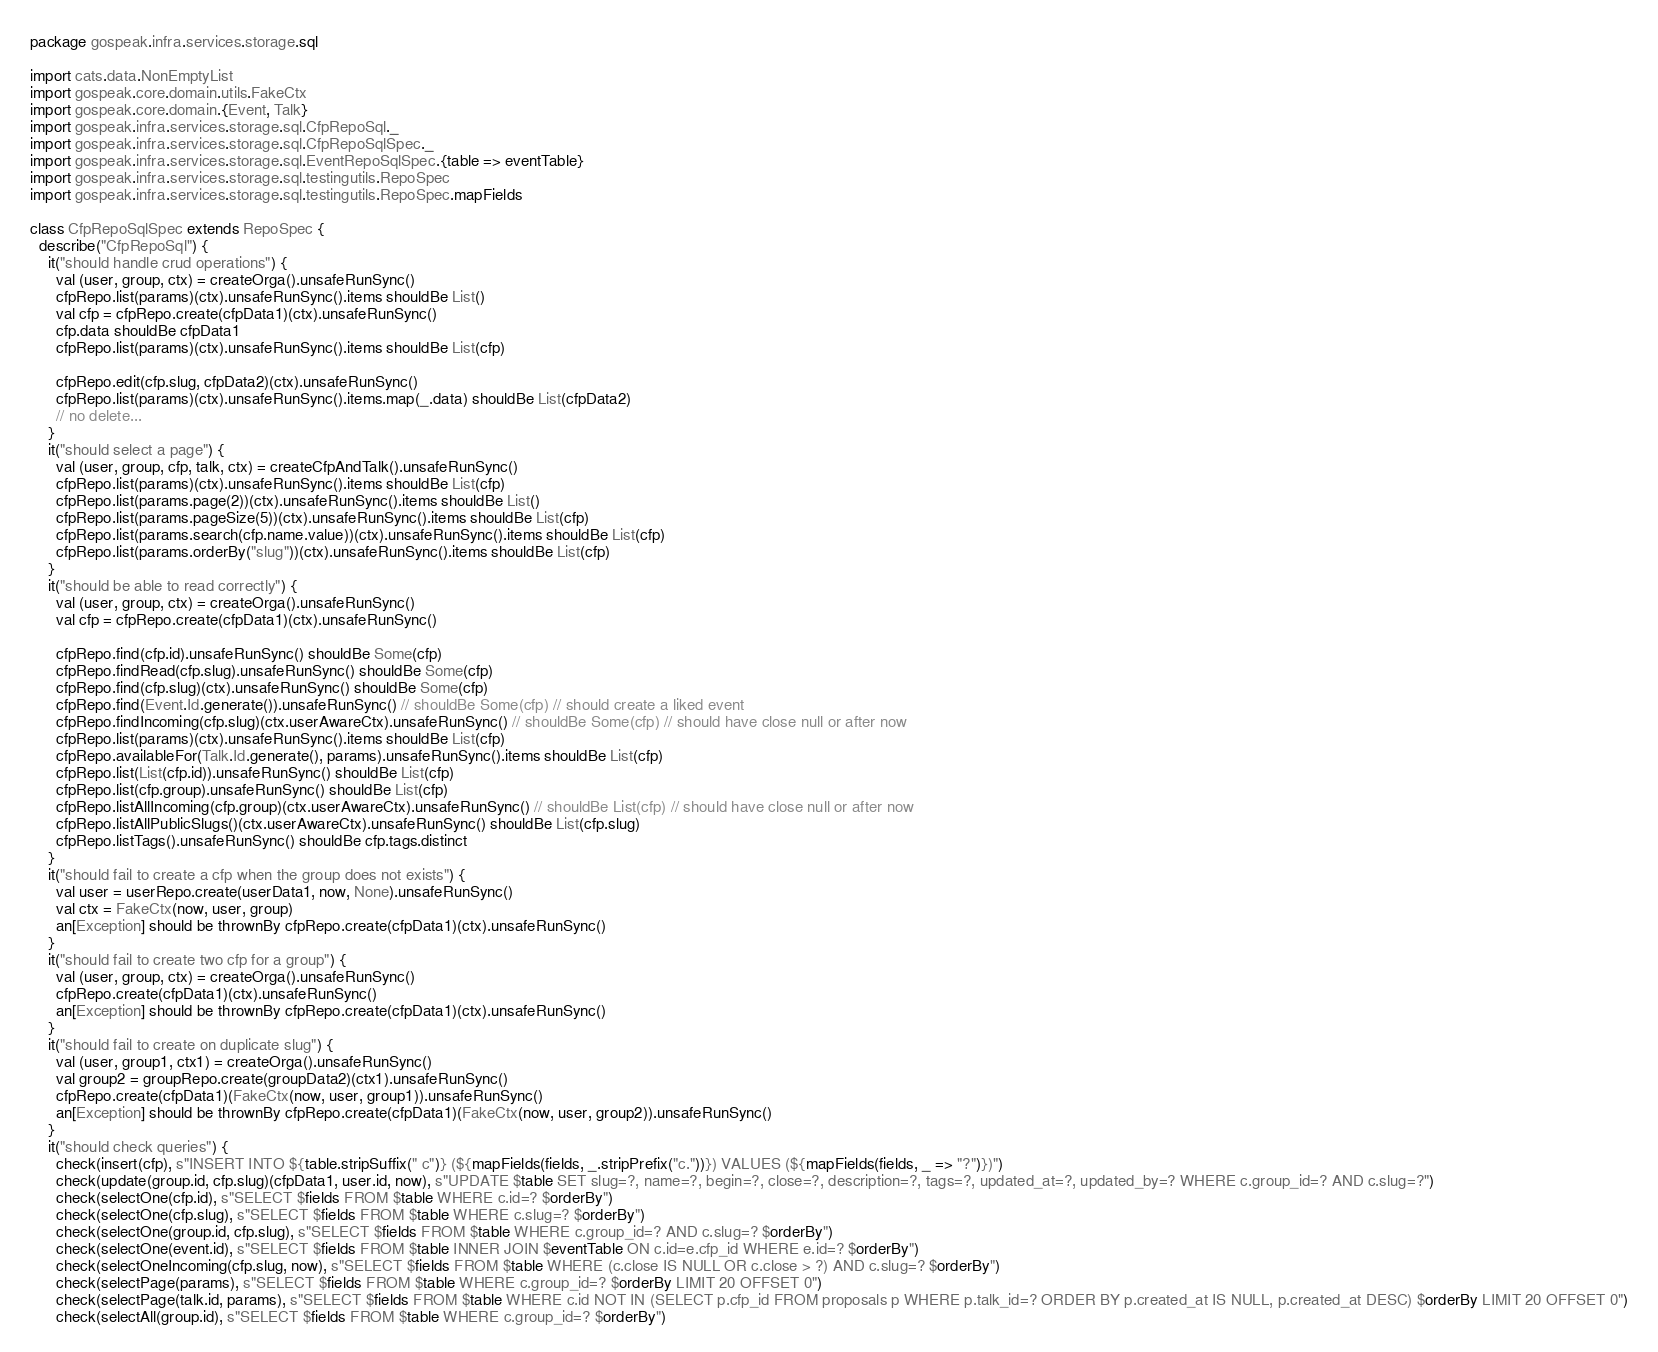Convert code to text. <code><loc_0><loc_0><loc_500><loc_500><_Scala_>package gospeak.infra.services.storage.sql

import cats.data.NonEmptyList
import gospeak.core.domain.utils.FakeCtx
import gospeak.core.domain.{Event, Talk}
import gospeak.infra.services.storage.sql.CfpRepoSql._
import gospeak.infra.services.storage.sql.CfpRepoSqlSpec._
import gospeak.infra.services.storage.sql.EventRepoSqlSpec.{table => eventTable}
import gospeak.infra.services.storage.sql.testingutils.RepoSpec
import gospeak.infra.services.storage.sql.testingutils.RepoSpec.mapFields

class CfpRepoSqlSpec extends RepoSpec {
  describe("CfpRepoSql") {
    it("should handle crud operations") {
      val (user, group, ctx) = createOrga().unsafeRunSync()
      cfpRepo.list(params)(ctx).unsafeRunSync().items shouldBe List()
      val cfp = cfpRepo.create(cfpData1)(ctx).unsafeRunSync()
      cfp.data shouldBe cfpData1
      cfpRepo.list(params)(ctx).unsafeRunSync().items shouldBe List(cfp)

      cfpRepo.edit(cfp.slug, cfpData2)(ctx).unsafeRunSync()
      cfpRepo.list(params)(ctx).unsafeRunSync().items.map(_.data) shouldBe List(cfpData2)
      // no delete...
    }
    it("should select a page") {
      val (user, group, cfp, talk, ctx) = createCfpAndTalk().unsafeRunSync()
      cfpRepo.list(params)(ctx).unsafeRunSync().items shouldBe List(cfp)
      cfpRepo.list(params.page(2))(ctx).unsafeRunSync().items shouldBe List()
      cfpRepo.list(params.pageSize(5))(ctx).unsafeRunSync().items shouldBe List(cfp)
      cfpRepo.list(params.search(cfp.name.value))(ctx).unsafeRunSync().items shouldBe List(cfp)
      cfpRepo.list(params.orderBy("slug"))(ctx).unsafeRunSync().items shouldBe List(cfp)
    }
    it("should be able to read correctly") {
      val (user, group, ctx) = createOrga().unsafeRunSync()
      val cfp = cfpRepo.create(cfpData1)(ctx).unsafeRunSync()

      cfpRepo.find(cfp.id).unsafeRunSync() shouldBe Some(cfp)
      cfpRepo.findRead(cfp.slug).unsafeRunSync() shouldBe Some(cfp)
      cfpRepo.find(cfp.slug)(ctx).unsafeRunSync() shouldBe Some(cfp)
      cfpRepo.find(Event.Id.generate()).unsafeRunSync() // shouldBe Some(cfp) // should create a liked event
      cfpRepo.findIncoming(cfp.slug)(ctx.userAwareCtx).unsafeRunSync() // shouldBe Some(cfp) // should have close null or after now
      cfpRepo.list(params)(ctx).unsafeRunSync().items shouldBe List(cfp)
      cfpRepo.availableFor(Talk.Id.generate(), params).unsafeRunSync().items shouldBe List(cfp)
      cfpRepo.list(List(cfp.id)).unsafeRunSync() shouldBe List(cfp)
      cfpRepo.list(cfp.group).unsafeRunSync() shouldBe List(cfp)
      cfpRepo.listAllIncoming(cfp.group)(ctx.userAwareCtx).unsafeRunSync() // shouldBe List(cfp) // should have close null or after now
      cfpRepo.listAllPublicSlugs()(ctx.userAwareCtx).unsafeRunSync() shouldBe List(cfp.slug)
      cfpRepo.listTags().unsafeRunSync() shouldBe cfp.tags.distinct
    }
    it("should fail to create a cfp when the group does not exists") {
      val user = userRepo.create(userData1, now, None).unsafeRunSync()
      val ctx = FakeCtx(now, user, group)
      an[Exception] should be thrownBy cfpRepo.create(cfpData1)(ctx).unsafeRunSync()
    }
    it("should fail to create two cfp for a group") {
      val (user, group, ctx) = createOrga().unsafeRunSync()
      cfpRepo.create(cfpData1)(ctx).unsafeRunSync()
      an[Exception] should be thrownBy cfpRepo.create(cfpData1)(ctx).unsafeRunSync()
    }
    it("should fail to create on duplicate slug") {
      val (user, group1, ctx1) = createOrga().unsafeRunSync()
      val group2 = groupRepo.create(groupData2)(ctx1).unsafeRunSync()
      cfpRepo.create(cfpData1)(FakeCtx(now, user, group1)).unsafeRunSync()
      an[Exception] should be thrownBy cfpRepo.create(cfpData1)(FakeCtx(now, user, group2)).unsafeRunSync()
    }
    it("should check queries") {
      check(insert(cfp), s"INSERT INTO ${table.stripSuffix(" c")} (${mapFields(fields, _.stripPrefix("c."))}) VALUES (${mapFields(fields, _ => "?")})")
      check(update(group.id, cfp.slug)(cfpData1, user.id, now), s"UPDATE $table SET slug=?, name=?, begin=?, close=?, description=?, tags=?, updated_at=?, updated_by=? WHERE c.group_id=? AND c.slug=?")
      check(selectOne(cfp.id), s"SELECT $fields FROM $table WHERE c.id=? $orderBy")
      check(selectOne(cfp.slug), s"SELECT $fields FROM $table WHERE c.slug=? $orderBy")
      check(selectOne(group.id, cfp.slug), s"SELECT $fields FROM $table WHERE c.group_id=? AND c.slug=? $orderBy")
      check(selectOne(event.id), s"SELECT $fields FROM $table INNER JOIN $eventTable ON c.id=e.cfp_id WHERE e.id=? $orderBy")
      check(selectOneIncoming(cfp.slug, now), s"SELECT $fields FROM $table WHERE (c.close IS NULL OR c.close > ?) AND c.slug=? $orderBy")
      check(selectPage(params), s"SELECT $fields FROM $table WHERE c.group_id=? $orderBy LIMIT 20 OFFSET 0")
      check(selectPage(talk.id, params), s"SELECT $fields FROM $table WHERE c.id NOT IN (SELECT p.cfp_id FROM proposals p WHERE p.talk_id=? ORDER BY p.created_at IS NULL, p.created_at DESC) $orderBy LIMIT 20 OFFSET 0")
      check(selectAll(group.id), s"SELECT $fields FROM $table WHERE c.group_id=? $orderBy")</code> 